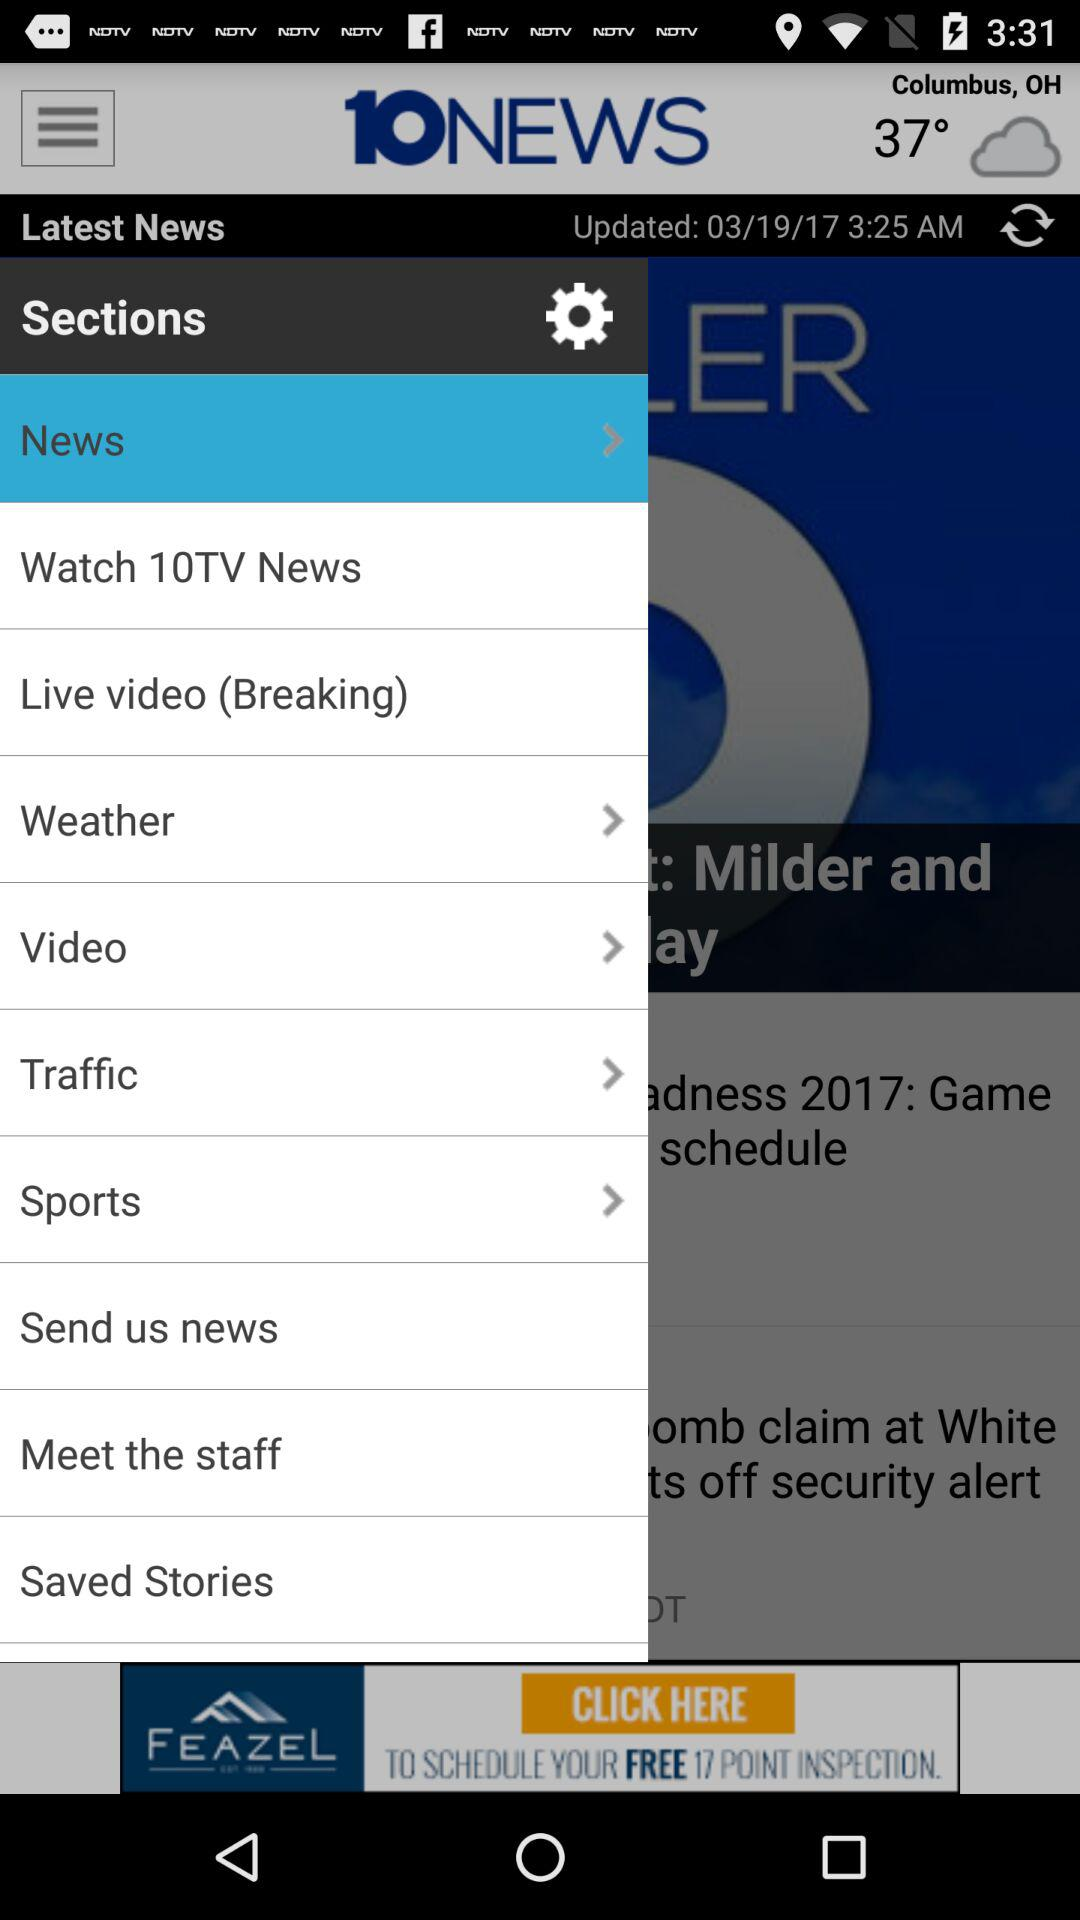What is the given temperature? The given temperature is 37°. 